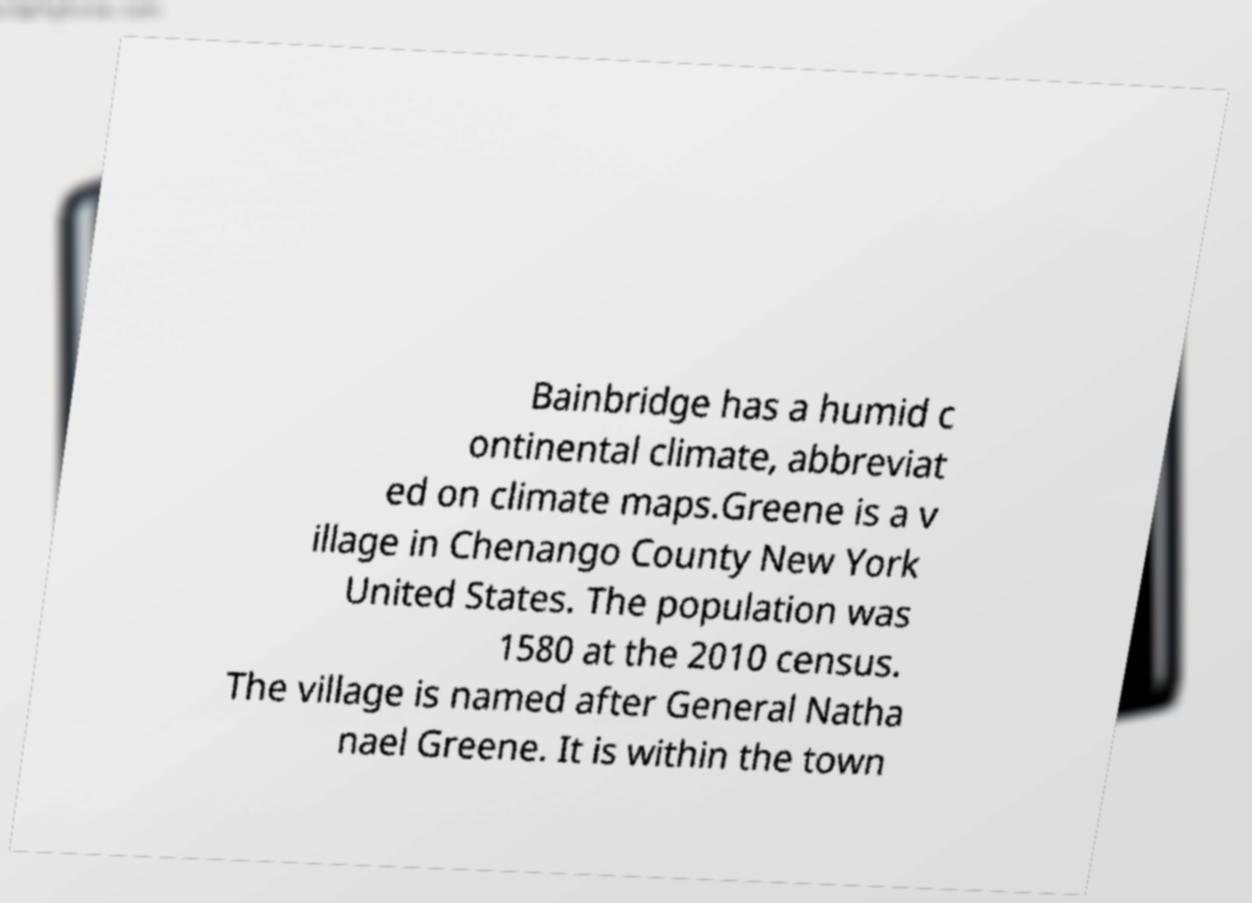I need the written content from this picture converted into text. Can you do that? Bainbridge has a humid c ontinental climate, abbreviat ed on climate maps.Greene is a v illage in Chenango County New York United States. The population was 1580 at the 2010 census. The village is named after General Natha nael Greene. It is within the town 